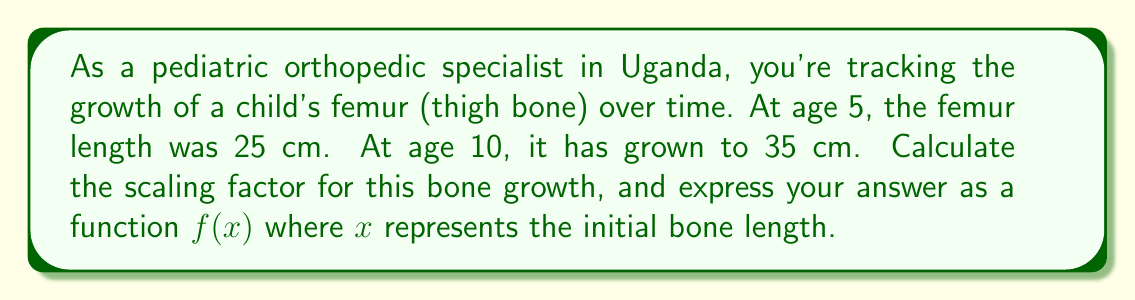Show me your answer to this math problem. Let's approach this step-by-step:

1) The scaling factor is the ratio of the new size to the original size. In mathematical terms, it's expressed as:

   $\text{Scaling factor} = \frac{\text{New size}}{\text{Original size}}$

2) In this case:
   Original size (at age 5) = 25 cm
   New size (at age 10) = 35 cm

3) Let's calculate the scaling factor:

   $\text{Scaling factor} = \frac{35 \text{ cm}}{25 \text{ cm}} = 1.4$

4) This means the bone has grown to 1.4 times its original length over this 5-year period.

5) To express this as a function $f(x)$ where $x$ represents the initial bone length:

   $f(x) = 1.4x$

   This function will take any initial bone length $x$ and scale it by a factor of 1.4.

6) We can verify this works for our original problem:
   $f(25) = 1.4 * 25 = 35$, which matches our new length at age 10.

Thus, the scaling factor function for this bone growth is $f(x) = 1.4x$.
Answer: $f(x) = 1.4x$ 